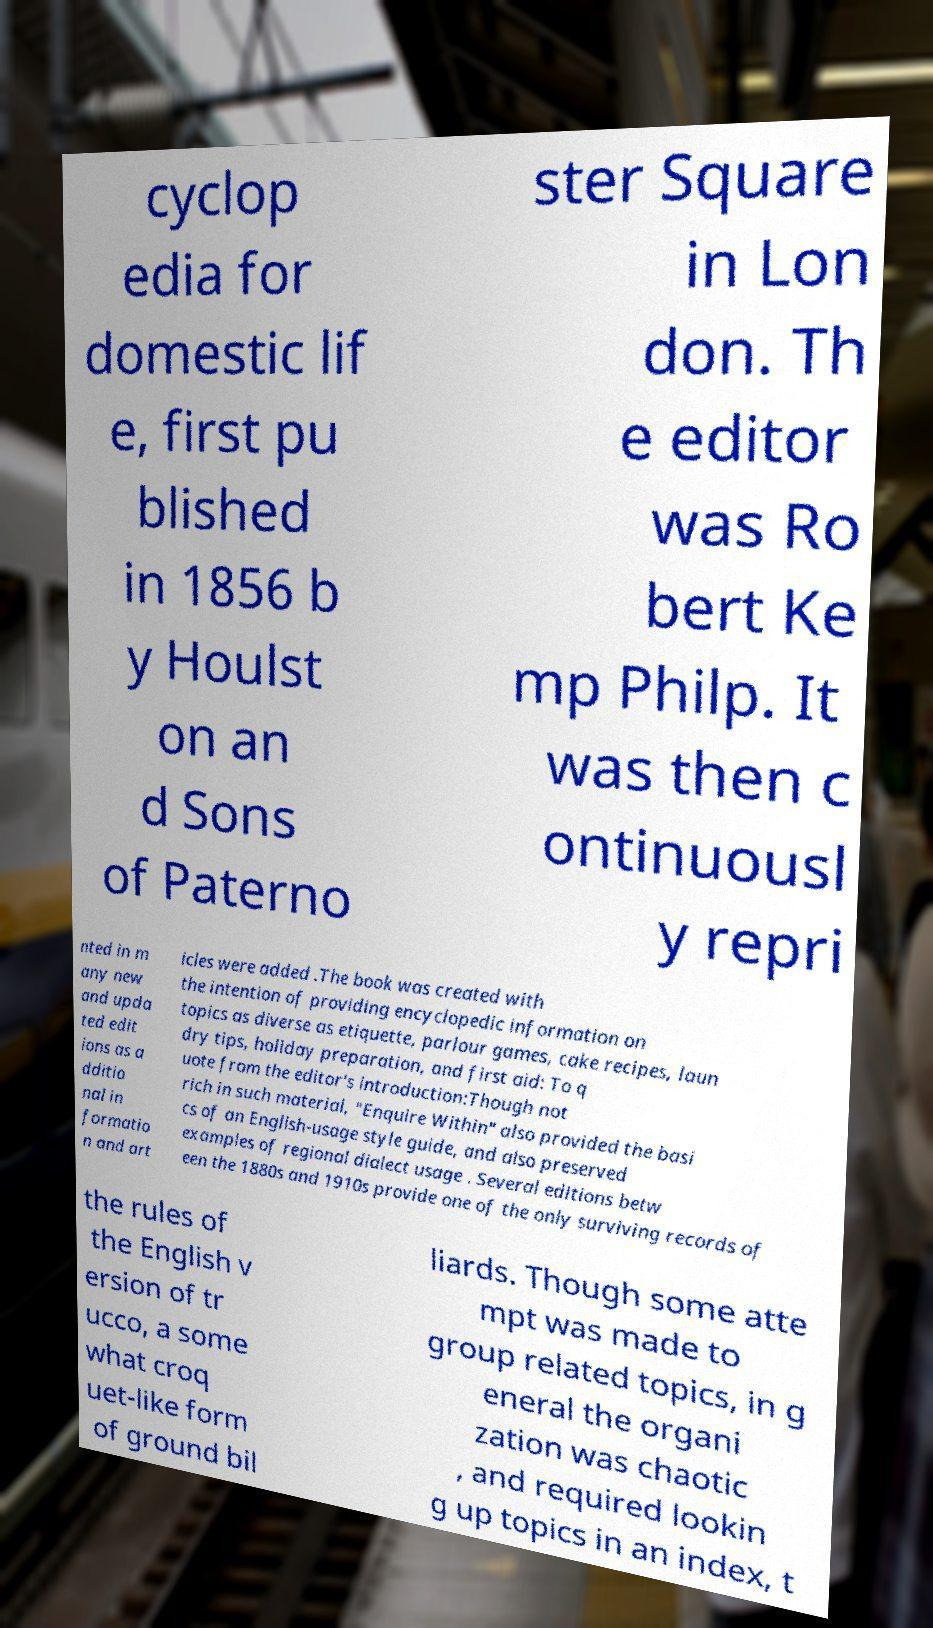Could you assist in decoding the text presented in this image and type it out clearly? cyclop edia for domestic lif e, first pu blished in 1856 b y Houlst on an d Sons of Paterno ster Square in Lon don. Th e editor was Ro bert Ke mp Philp. It was then c ontinuousl y repri nted in m any new and upda ted edit ions as a dditio nal in formatio n and art icles were added .The book was created with the intention of providing encyclopedic information on topics as diverse as etiquette, parlour games, cake recipes, laun dry tips, holiday preparation, and first aid: To q uote from the editor's introduction:Though not rich in such material, "Enquire Within" also provided the basi cs of an English-usage style guide, and also preserved examples of regional dialect usage . Several editions betw een the 1880s and 1910s provide one of the only surviving records of the rules of the English v ersion of tr ucco, a some what croq uet-like form of ground bil liards. Though some atte mpt was made to group related topics, in g eneral the organi zation was chaotic , and required lookin g up topics in an index, t 